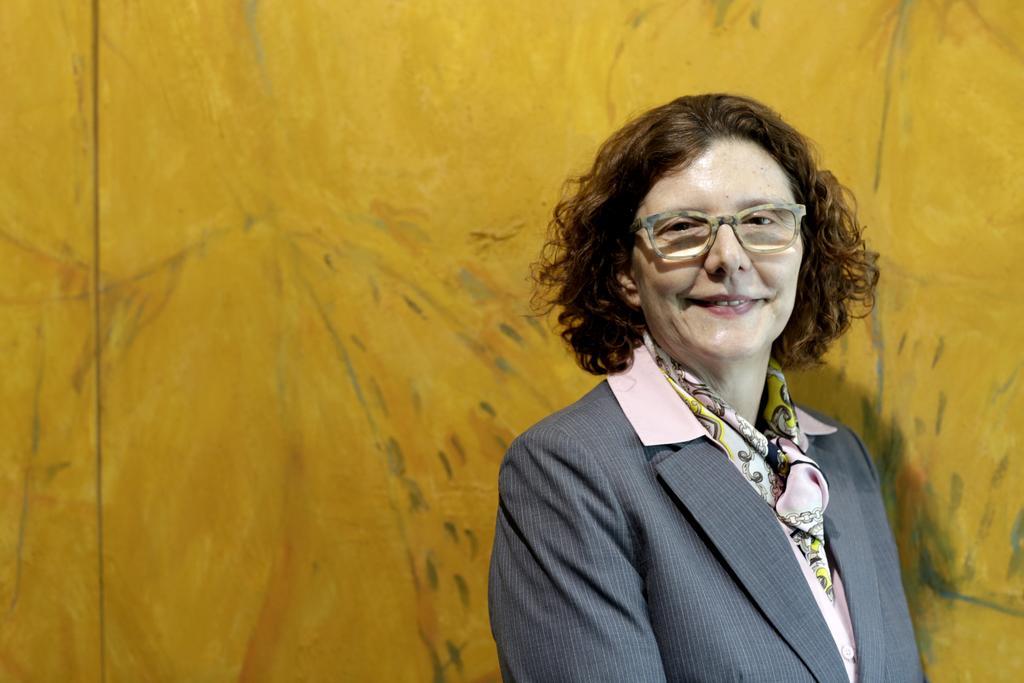How would you summarize this image in a sentence or two? In this image we can see a woman and she is smiling. She wore spectacles. There is a yellow color background. 